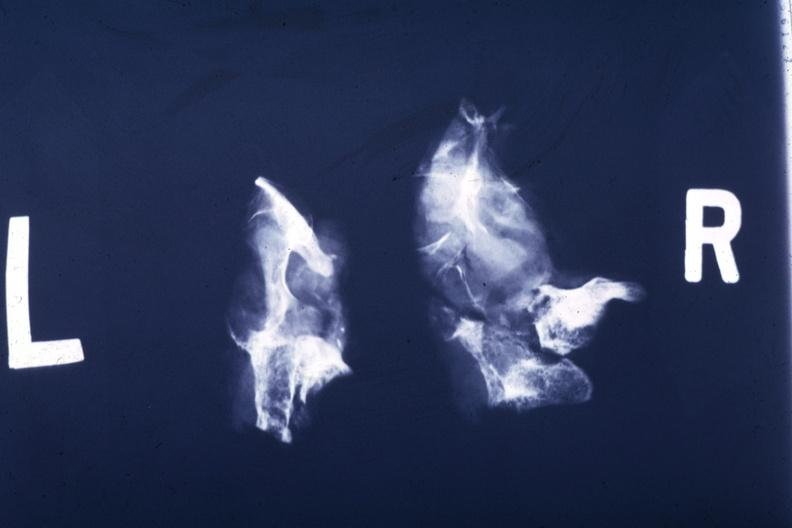s endocrine present?
Answer the question using a single word or phrase. Yes 